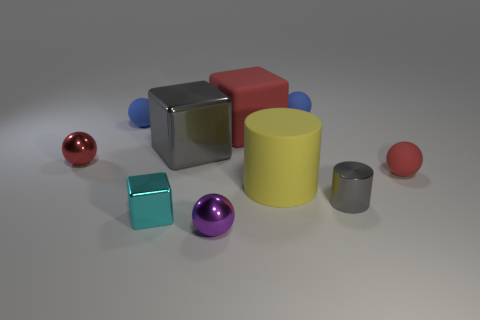Which objects in the image are the largest and the smallest? The largest object is the yellow cylinder, which dominates by its height and volume. In contrast, the smallest is the small red sphere, which is diminutive in size compared to the other objects. This contrast between the largest and smallest items adds an interesting hierarchy of scale to the scene. 